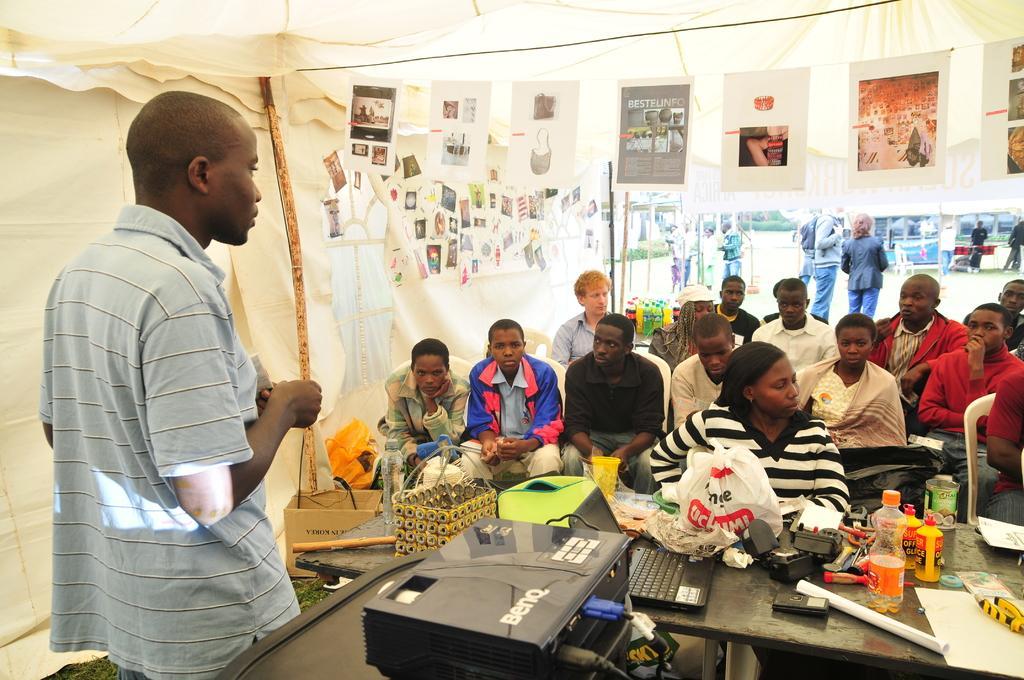Please provide a concise description of this image. In this image, on the left there is a man, he wears a t shirt. In the middle there is a table on that there are bottles, covers, projector, laptop, papers, some other items. In the middle there are people sitting on the chairs. In the background there are posters, papers, tents, people and road. 